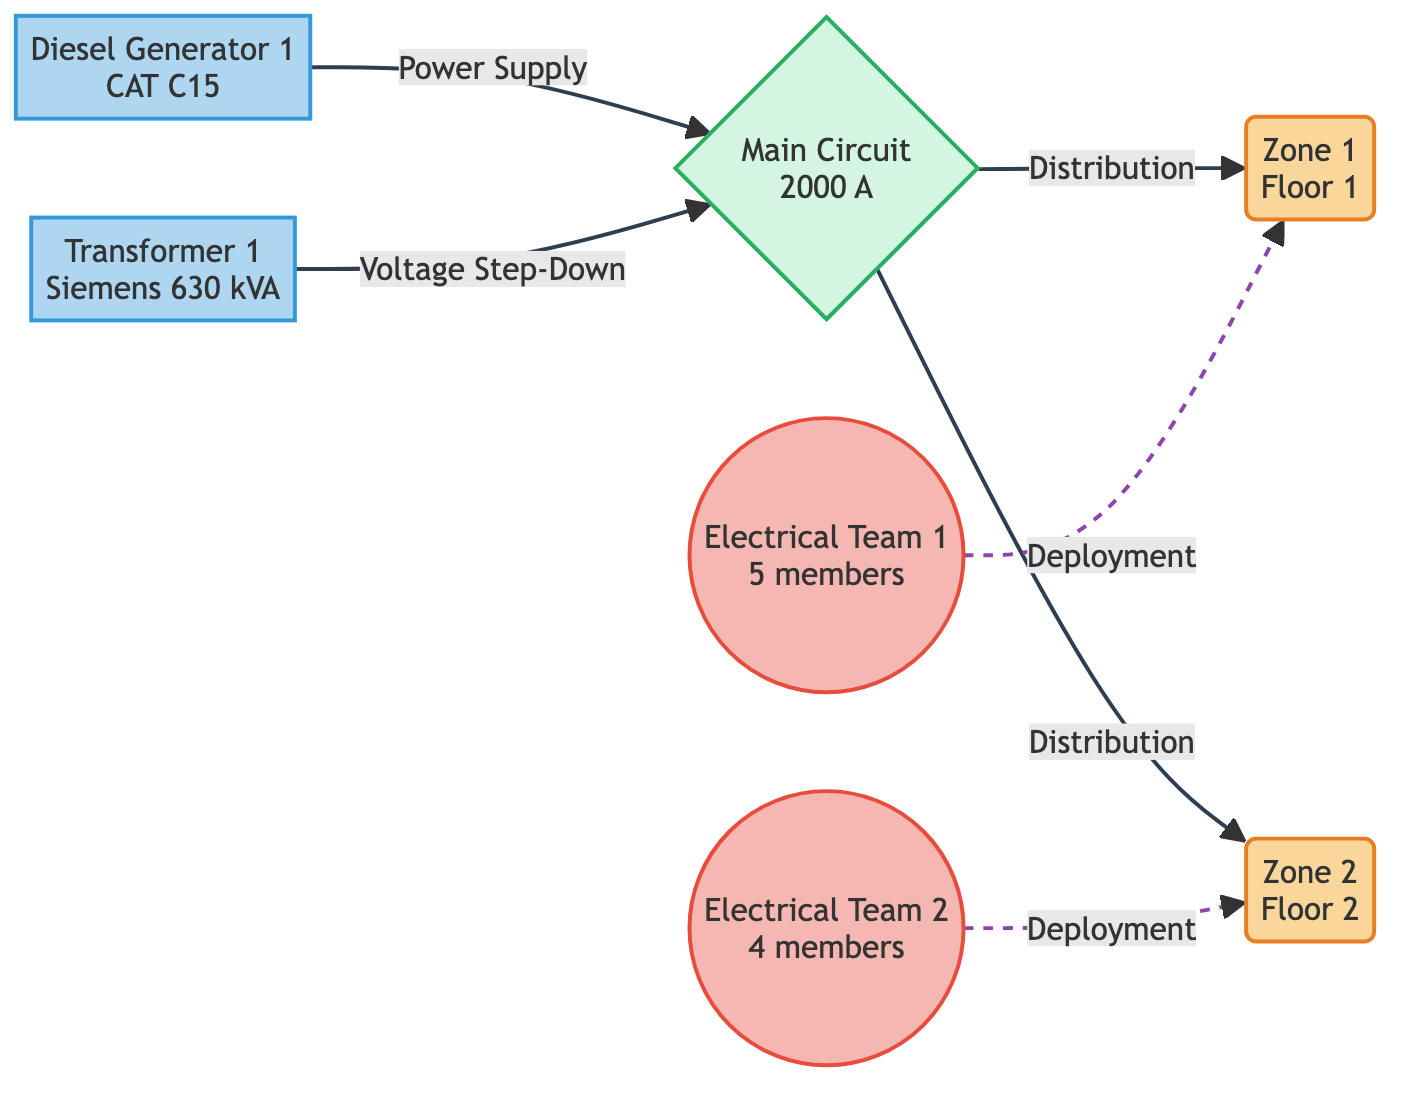What are the two zones represented in the diagram? The diagram shows two zones labeled as "Zone 1" and "Zone 2".
Answer: Zone 1, Zone 2 How many members are in Electrical Team 2? Electrical Team 2 is represented with a label indicating that it has 4 members.
Answer: 4 What is the model of the Diesel Generator? The Diesel Generator is labeled with the model "CAT C15".
Answer: CAT C15 Which resources are deployed in Zone 1? Zone 1 has the resource "Electrical Team 1" deployed to it according to the diagram's links.
Answer: Electrical Team 1 What is the capacity of the Main Circuit? The capacity of the Main Circuit is labeled as "2000 A".
Answer: 2000 A What type of link connects the Diesel Generator to the Main Circuit? The link between the Diesel Generator and the Main Circuit is labeled as "Power Supply".
Answer: Power Supply How many electrical teams are represented in the network? There are two electrical teams labeled in the diagram, namely "Electrical Team 1" and "Electrical Team 2".
Answer: 2 Which equipment provides voltage step-down in the diagram? The equipment providing voltage step-down is labeled as "Transformer 1".
Answer: Transformer 1 Which zone is connected to the Electrical Team 1? The diagram shows that Electrical Team 1 is connected to Zone 1 through a "Deployment" link.
Answer: Zone 1 